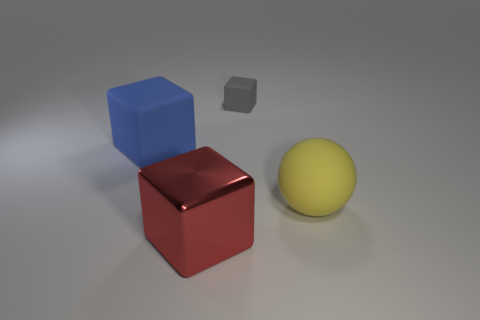Add 3 red rubber cylinders. How many objects exist? 7 Subtract all balls. How many objects are left? 3 Subtract 1 gray cubes. How many objects are left? 3 Subtract all large blue objects. Subtract all yellow objects. How many objects are left? 2 Add 3 yellow matte spheres. How many yellow matte spheres are left? 4 Add 4 large green spheres. How many large green spheres exist? 4 